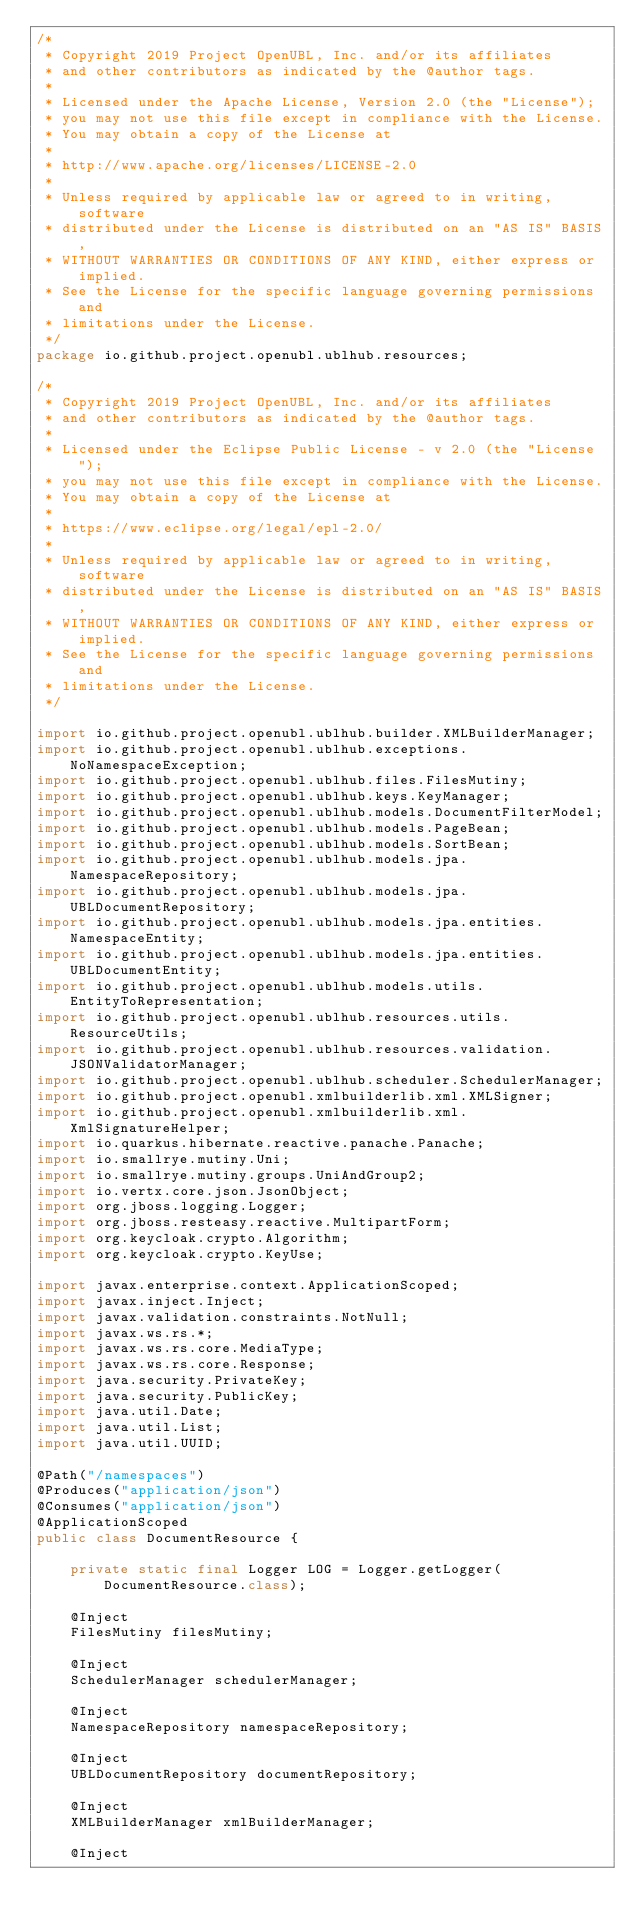<code> <loc_0><loc_0><loc_500><loc_500><_Java_>/*
 * Copyright 2019 Project OpenUBL, Inc. and/or its affiliates
 * and other contributors as indicated by the @author tags.
 *
 * Licensed under the Apache License, Version 2.0 (the "License");
 * you may not use this file except in compliance with the License.
 * You may obtain a copy of the License at
 *
 * http://www.apache.org/licenses/LICENSE-2.0
 *
 * Unless required by applicable law or agreed to in writing, software
 * distributed under the License is distributed on an "AS IS" BASIS,
 * WITHOUT WARRANTIES OR CONDITIONS OF ANY KIND, either express or implied.
 * See the License for the specific language governing permissions and
 * limitations under the License.
 */
package io.github.project.openubl.ublhub.resources;

/*
 * Copyright 2019 Project OpenUBL, Inc. and/or its affiliates
 * and other contributors as indicated by the @author tags.
 *
 * Licensed under the Eclipse Public License - v 2.0 (the "License");
 * you may not use this file except in compliance with the License.
 * You may obtain a copy of the License at
 *
 * https://www.eclipse.org/legal/epl-2.0/
 *
 * Unless required by applicable law or agreed to in writing, software
 * distributed under the License is distributed on an "AS IS" BASIS,
 * WITHOUT WARRANTIES OR CONDITIONS OF ANY KIND, either express or implied.
 * See the License for the specific language governing permissions and
 * limitations under the License.
 */

import io.github.project.openubl.ublhub.builder.XMLBuilderManager;
import io.github.project.openubl.ublhub.exceptions.NoNamespaceException;
import io.github.project.openubl.ublhub.files.FilesMutiny;
import io.github.project.openubl.ublhub.keys.KeyManager;
import io.github.project.openubl.ublhub.models.DocumentFilterModel;
import io.github.project.openubl.ublhub.models.PageBean;
import io.github.project.openubl.ublhub.models.SortBean;
import io.github.project.openubl.ublhub.models.jpa.NamespaceRepository;
import io.github.project.openubl.ublhub.models.jpa.UBLDocumentRepository;
import io.github.project.openubl.ublhub.models.jpa.entities.NamespaceEntity;
import io.github.project.openubl.ublhub.models.jpa.entities.UBLDocumentEntity;
import io.github.project.openubl.ublhub.models.utils.EntityToRepresentation;
import io.github.project.openubl.ublhub.resources.utils.ResourceUtils;
import io.github.project.openubl.ublhub.resources.validation.JSONValidatorManager;
import io.github.project.openubl.ublhub.scheduler.SchedulerManager;
import io.github.project.openubl.xmlbuilderlib.xml.XMLSigner;
import io.github.project.openubl.xmlbuilderlib.xml.XmlSignatureHelper;
import io.quarkus.hibernate.reactive.panache.Panache;
import io.smallrye.mutiny.Uni;
import io.smallrye.mutiny.groups.UniAndGroup2;
import io.vertx.core.json.JsonObject;
import org.jboss.logging.Logger;
import org.jboss.resteasy.reactive.MultipartForm;
import org.keycloak.crypto.Algorithm;
import org.keycloak.crypto.KeyUse;

import javax.enterprise.context.ApplicationScoped;
import javax.inject.Inject;
import javax.validation.constraints.NotNull;
import javax.ws.rs.*;
import javax.ws.rs.core.MediaType;
import javax.ws.rs.core.Response;
import java.security.PrivateKey;
import java.security.PublicKey;
import java.util.Date;
import java.util.List;
import java.util.UUID;

@Path("/namespaces")
@Produces("application/json")
@Consumes("application/json")
@ApplicationScoped
public class DocumentResource {

    private static final Logger LOG = Logger.getLogger(DocumentResource.class);

    @Inject
    FilesMutiny filesMutiny;

    @Inject
    SchedulerManager schedulerManager;

    @Inject
    NamespaceRepository namespaceRepository;

    @Inject
    UBLDocumentRepository documentRepository;

    @Inject
    XMLBuilderManager xmlBuilderManager;

    @Inject</code> 